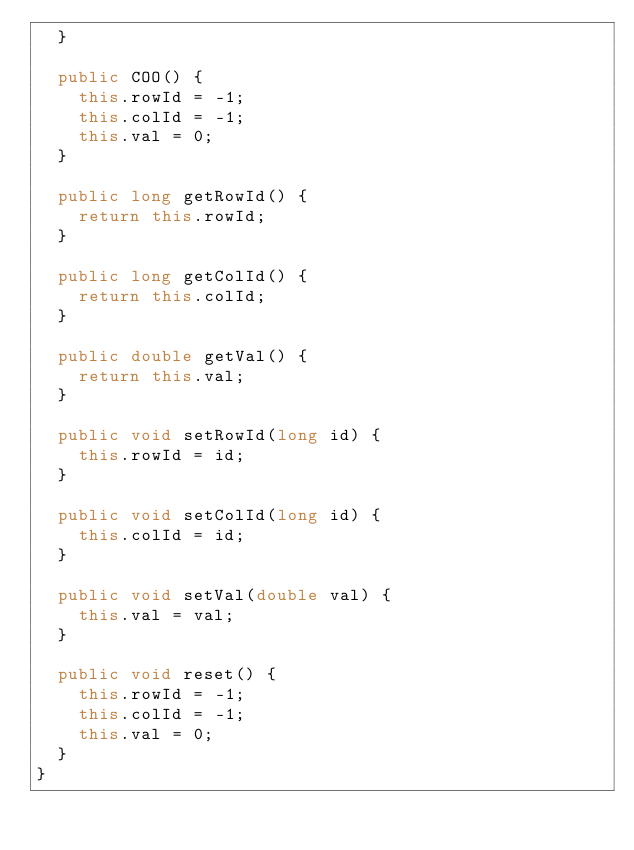Convert code to text. <code><loc_0><loc_0><loc_500><loc_500><_Java_>  }

  public COO() {
    this.rowId = -1;
    this.colId = -1;
    this.val = 0;
  }

  public long getRowId() {
    return this.rowId;
  }

  public long getColId() {
    return this.colId;
  }

  public double getVal() {
    return this.val;
  }

  public void setRowId(long id) {
    this.rowId = id;
  }

  public void setColId(long id) {
    this.colId = id;
  }

  public void setVal(double val) {
    this.val = val;
  }

  public void reset() {
    this.rowId = -1;
    this.colId = -1;
    this.val = 0;
  }
}

</code> 